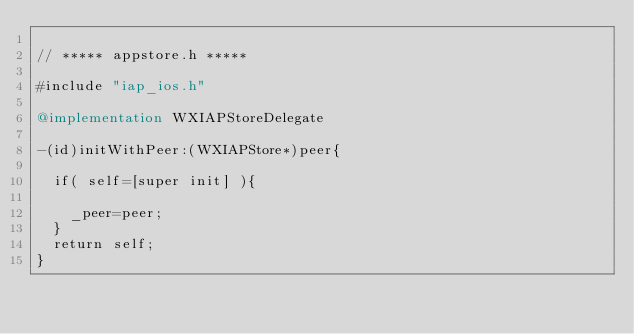Convert code to text. <code><loc_0><loc_0><loc_500><loc_500><_ObjectiveC_>
// ***** appstore.h *****

#include "iap_ios.h"

@implementation WXIAPStoreDelegate

-(id)initWithPeer:(WXIAPStore*)peer{

	if( self=[super init] ){
	
		_peer=peer;
	}
	return self;
}
</code> 